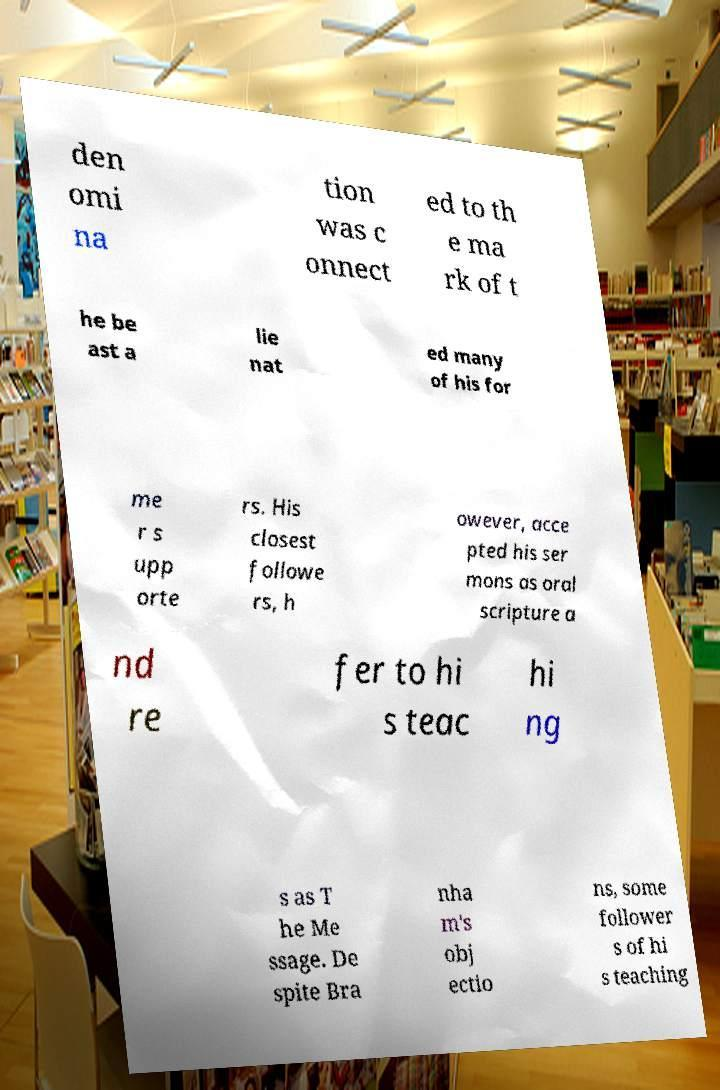Please identify and transcribe the text found in this image. den omi na tion was c onnect ed to th e ma rk of t he be ast a lie nat ed many of his for me r s upp orte rs. His closest followe rs, h owever, acce pted his ser mons as oral scripture a nd re fer to hi s teac hi ng s as T he Me ssage. De spite Bra nha m's obj ectio ns, some follower s of hi s teaching 